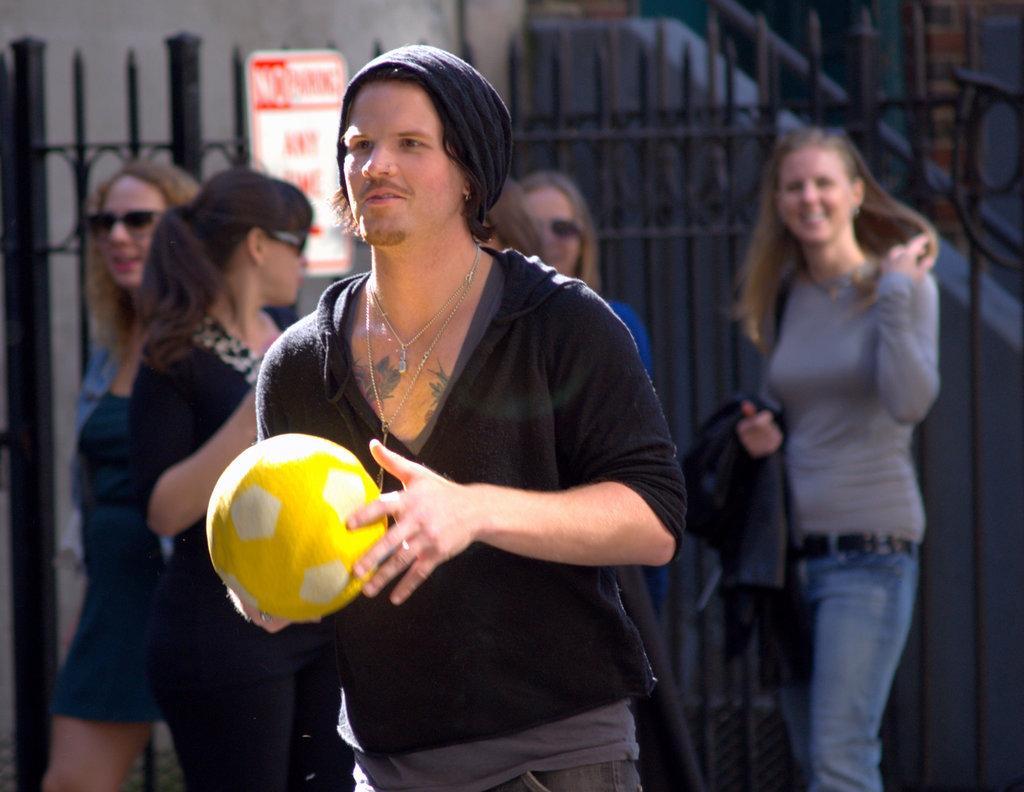Could you give a brief overview of what you see in this image? In this image we can see some people standing on the ground. One man is holding a ball in his hands. In the background, we can see metal fence and a board with some text. 